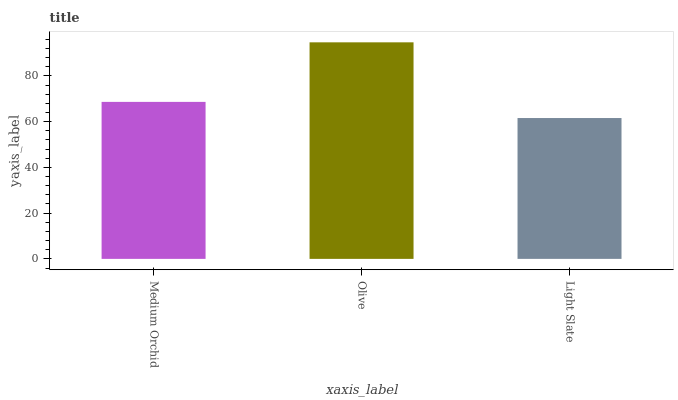Is Olive the minimum?
Answer yes or no. No. Is Light Slate the maximum?
Answer yes or no. No. Is Olive greater than Light Slate?
Answer yes or no. Yes. Is Light Slate less than Olive?
Answer yes or no. Yes. Is Light Slate greater than Olive?
Answer yes or no. No. Is Olive less than Light Slate?
Answer yes or no. No. Is Medium Orchid the high median?
Answer yes or no. Yes. Is Medium Orchid the low median?
Answer yes or no. Yes. Is Light Slate the high median?
Answer yes or no. No. Is Light Slate the low median?
Answer yes or no. No. 